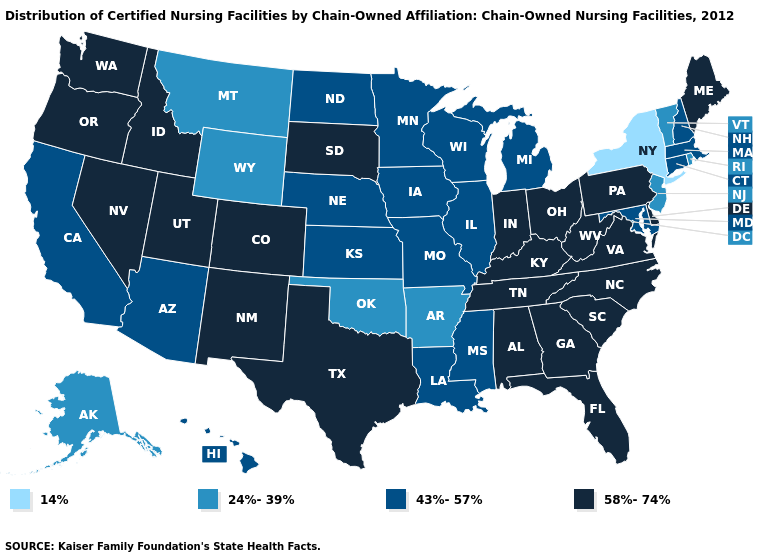How many symbols are there in the legend?
Short answer required. 4. What is the value of North Dakota?
Short answer required. 43%-57%. What is the lowest value in the Northeast?
Write a very short answer. 14%. Name the states that have a value in the range 58%-74%?
Answer briefly. Alabama, Colorado, Delaware, Florida, Georgia, Idaho, Indiana, Kentucky, Maine, Nevada, New Mexico, North Carolina, Ohio, Oregon, Pennsylvania, South Carolina, South Dakota, Tennessee, Texas, Utah, Virginia, Washington, West Virginia. Which states have the lowest value in the South?
Keep it brief. Arkansas, Oklahoma. Which states hav the highest value in the Northeast?
Short answer required. Maine, Pennsylvania. Name the states that have a value in the range 43%-57%?
Give a very brief answer. Arizona, California, Connecticut, Hawaii, Illinois, Iowa, Kansas, Louisiana, Maryland, Massachusetts, Michigan, Minnesota, Mississippi, Missouri, Nebraska, New Hampshire, North Dakota, Wisconsin. Does the map have missing data?
Be succinct. No. What is the value of West Virginia?
Keep it brief. 58%-74%. Name the states that have a value in the range 24%-39%?
Be succinct. Alaska, Arkansas, Montana, New Jersey, Oklahoma, Rhode Island, Vermont, Wyoming. What is the value of Wyoming?
Write a very short answer. 24%-39%. What is the value of Nevada?
Short answer required. 58%-74%. Name the states that have a value in the range 24%-39%?
Quick response, please. Alaska, Arkansas, Montana, New Jersey, Oklahoma, Rhode Island, Vermont, Wyoming. Does the first symbol in the legend represent the smallest category?
Quick response, please. Yes. 